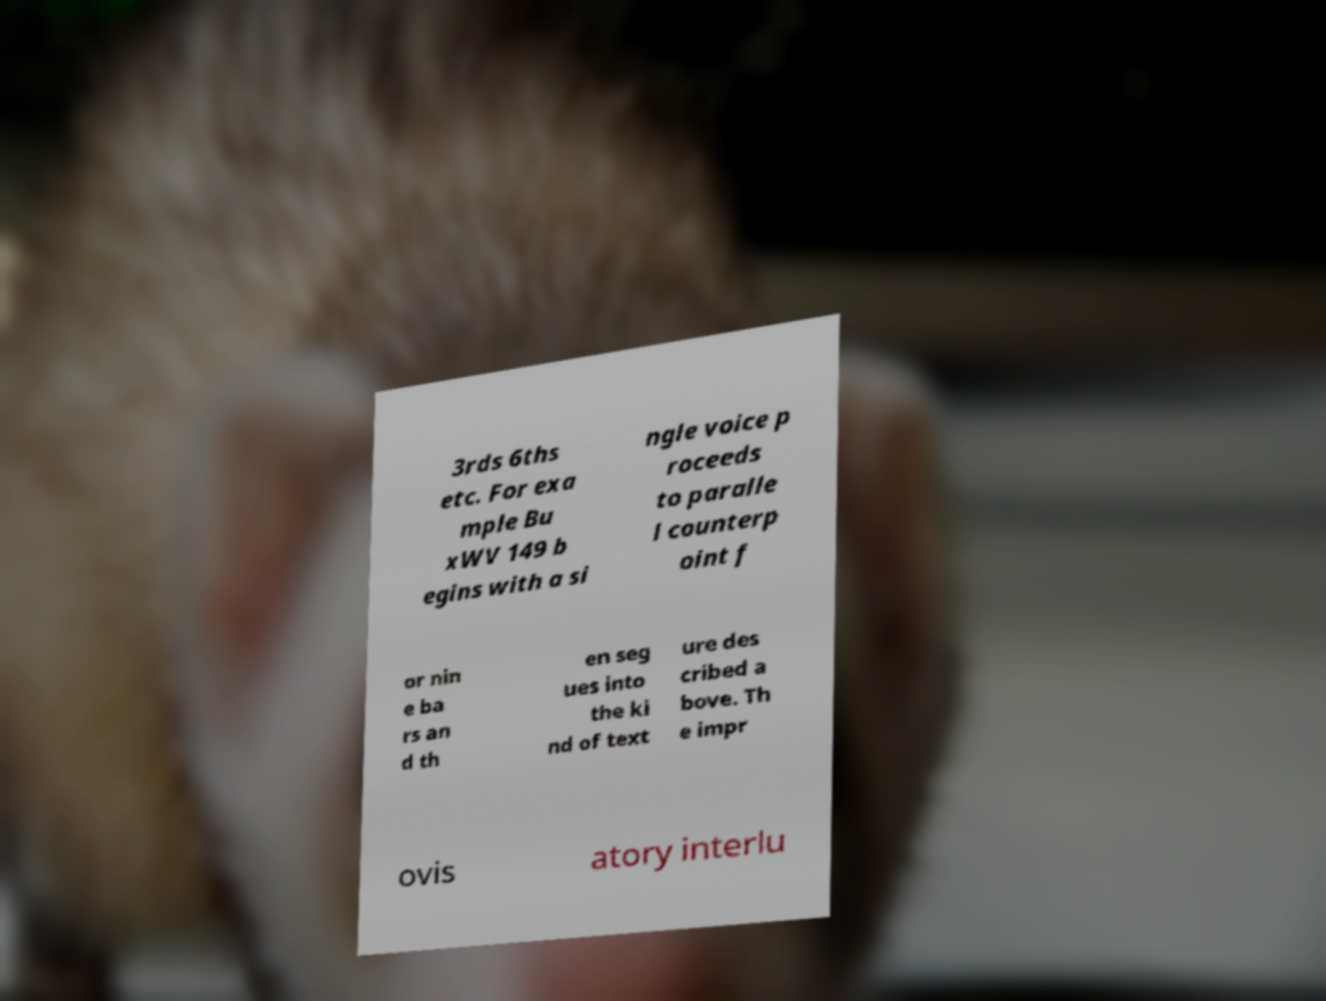Can you accurately transcribe the text from the provided image for me? 3rds 6ths etc. For exa mple Bu xWV 149 b egins with a si ngle voice p roceeds to paralle l counterp oint f or nin e ba rs an d th en seg ues into the ki nd of text ure des cribed a bove. Th e impr ovis atory interlu 